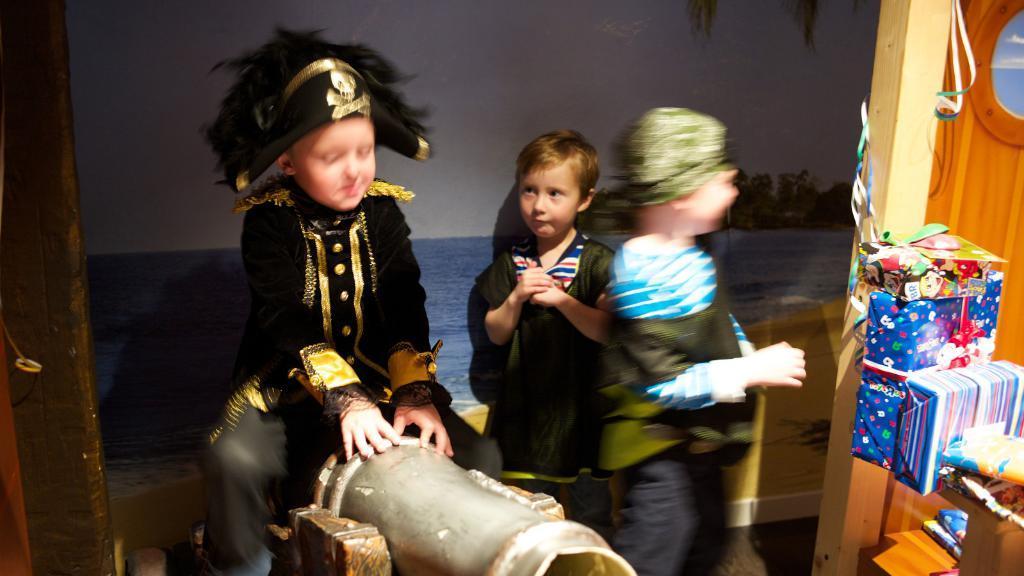Describe this image in one or two sentences. In this picture I can see there is a kid sitting on the grey object and he is wearing a black coat and a hat and there are two other kids on to the right. There are some gift wrappers and gifts here and there is a banner in the backdrop. 